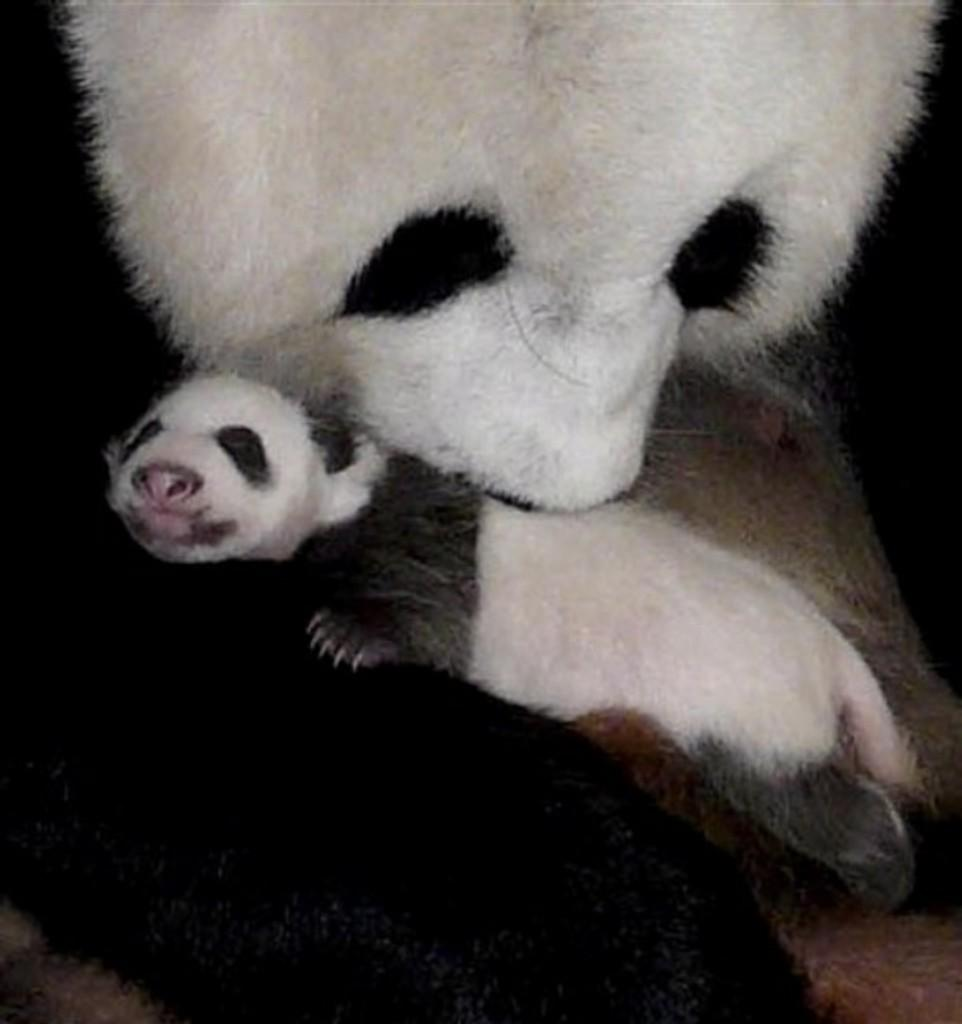What type of animals can be seen in the image? The image contains animals visible on the surface. Can you describe the animals in more detail? Unfortunately, the facts provided do not give any specific details about the animals. Are the animals in a natural or man-made environment? The facts provided do not specify whether the animals are in a natural or man-made environment. What invention can be seen in the image? There is no invention present in the image; it only contains animals visible on the surface. 